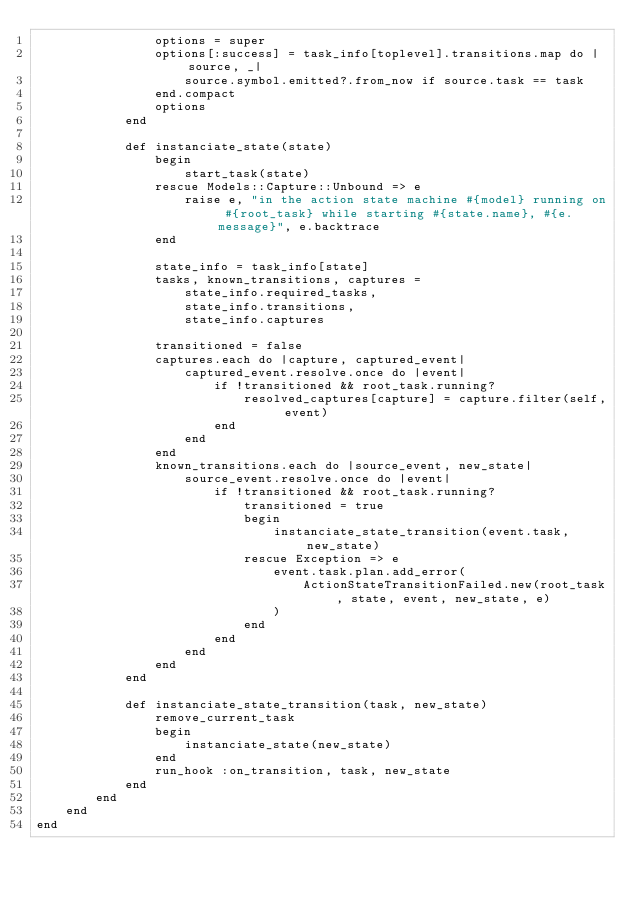Convert code to text. <code><loc_0><loc_0><loc_500><loc_500><_Ruby_>                options = super
                options[:success] = task_info[toplevel].transitions.map do |source, _|
                    source.symbol.emitted?.from_now if source.task == task
                end.compact
                options
            end

            def instanciate_state(state)
                begin
                    start_task(state)
                rescue Models::Capture::Unbound => e
                    raise e, "in the action state machine #{model} running on #{root_task} while starting #{state.name}, #{e.message}", e.backtrace
                end

                state_info = task_info[state]
                tasks, known_transitions, captures =
                    state_info.required_tasks,
                    state_info.transitions,
                    state_info.captures

                transitioned = false
                captures.each do |capture, captured_event|
                    captured_event.resolve.once do |event|
                        if !transitioned && root_task.running?
                            resolved_captures[capture] = capture.filter(self, event)
                        end
                    end
                end
                known_transitions.each do |source_event, new_state|
                    source_event.resolve.once do |event|
                        if !transitioned && root_task.running?
                            transitioned = true
                            begin
                                instanciate_state_transition(event.task, new_state)
                            rescue Exception => e
                                event.task.plan.add_error(
                                    ActionStateTransitionFailed.new(root_task, state, event, new_state, e)
                                )
                            end
                        end
                    end
                end
            end

            def instanciate_state_transition(task, new_state)
                remove_current_task
                begin
                    instanciate_state(new_state)
                end
                run_hook :on_transition, task, new_state
            end
        end
    end
end

</code> 